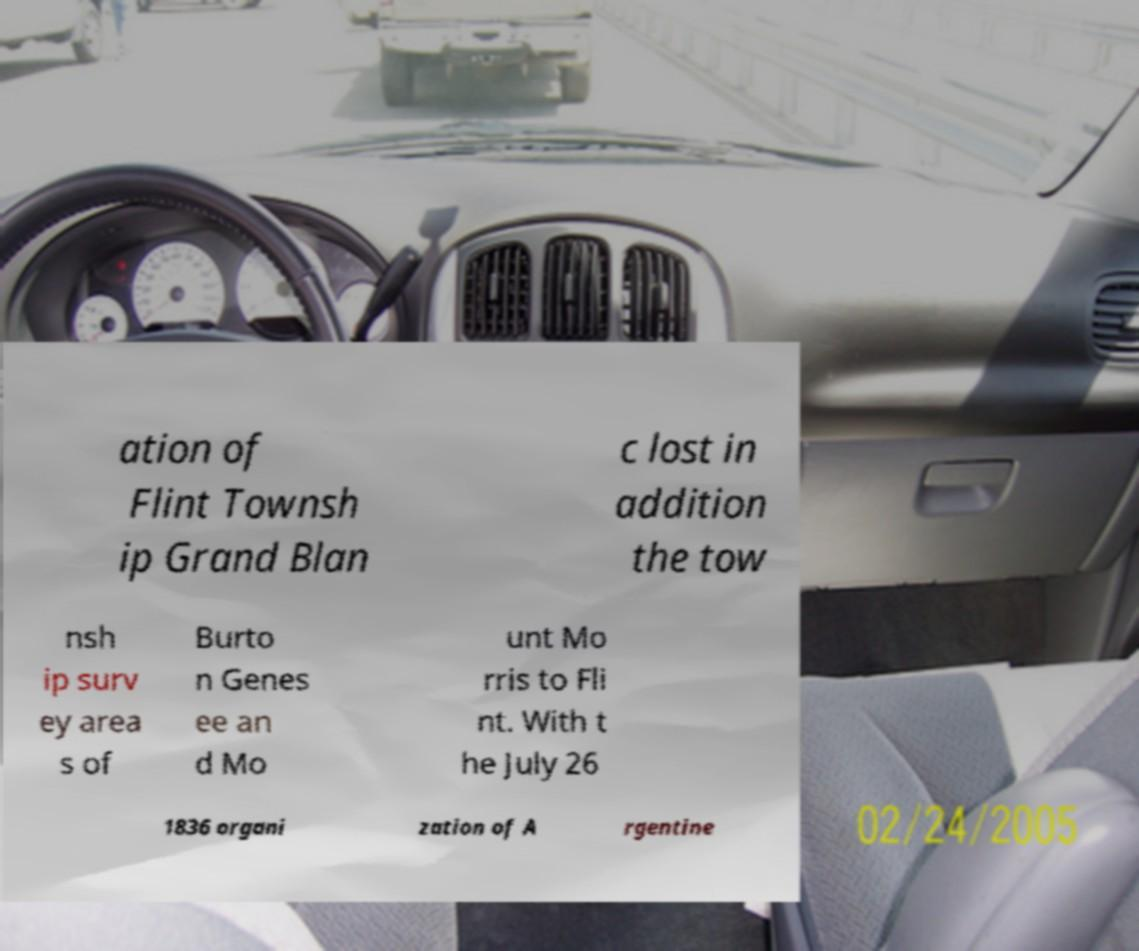Please read and relay the text visible in this image. What does it say? ation of Flint Townsh ip Grand Blan c lost in addition the tow nsh ip surv ey area s of Burto n Genes ee an d Mo unt Mo rris to Fli nt. With t he July 26 1836 organi zation of A rgentine 